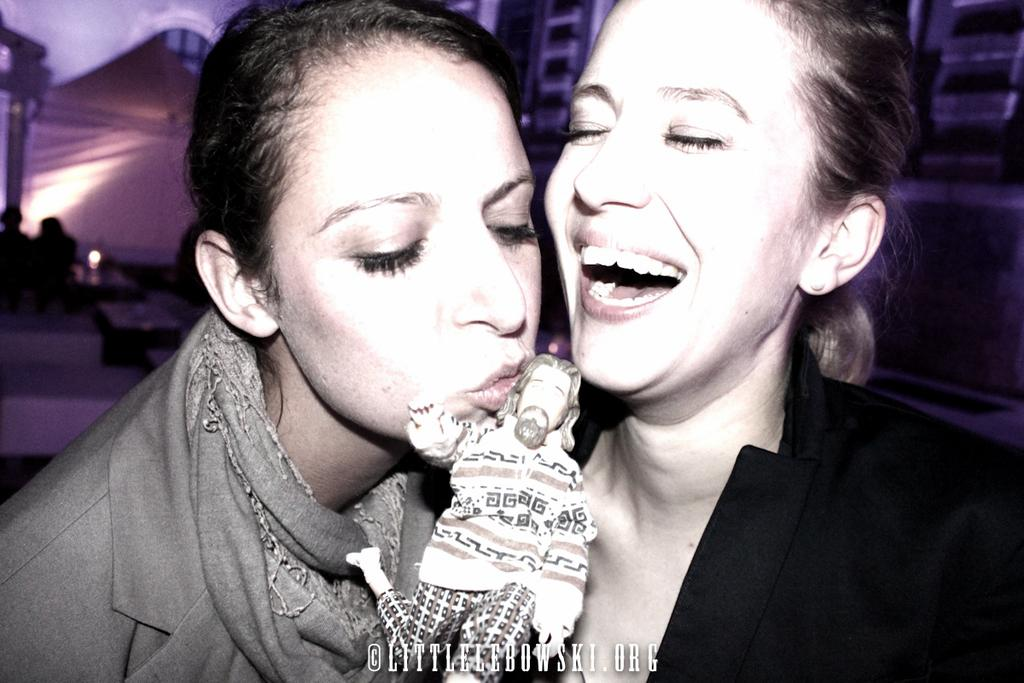What is the woman in the image doing? The woman is kissing a toy in the image. Can you describe the expression of the second woman in the image? The second woman is smiling in the image. What can be seen in the background of the image? There are persons, tables, and a wall visible in the background of the image. What type of industry is depicted in the image? There is no industry depicted in the image; it features two women and a toy. How does the lace on the woman's dress draw attention in the image? There is no mention of lace or a dress in the image; the woman is kissing a toy, and the second woman is smiling. 